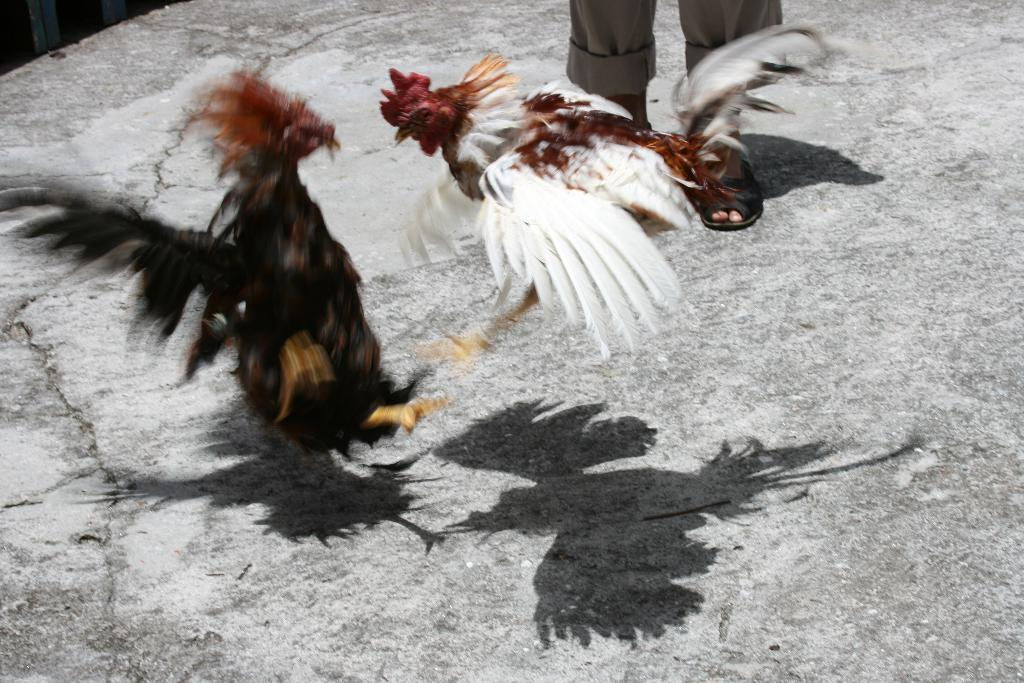What is happening in the center of the image? There are two hens fighting in the center of the image. Can you describe the background of the image? There is a person standing in the background of the image. What is located at the bottom of the image? There is a walkway at the bottom of the image. What type of war is being fought by the band in the image? There is no war or band present in the image; it features two hens fighting and a person standing in the background. 